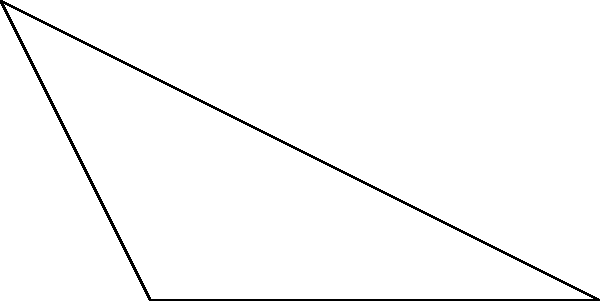Dearie, at the last concert, I noticed two microphone stands on stage forming an interesting angle. If one stand was 3 feet from the center of the stage and the other was $\sqrt{10}$ feet away, with an angle of $\theta$ between them, what's the cosine of that angle? It reminds me of those geometry problems from school! Let's work through this step-by-step, like solving a puzzle:

1) First, we can see a triangle formed by the two microphone stands and the center of the stage. Let's call the center point O, and the stands A and B.

2) We know that:
   OA = 3 feet
   OB = $\sqrt{10}$ feet
   Angle AOB = $\theta$

3) In trigonometry, there's a useful formula called the cosine law. It states that for a triangle with sides a, b, c and an angle C opposite side c:

   $c^2 = a^2 + b^2 - 2ab \cos(C)$

4) In our case, we want to find $\cos(\theta)$. We can use AB as our c, OA as a, and OB as b.

5) We don't know AB, but we can find it using the cosine law:

   $AB^2 = OA^2 + OB^2 - 2(OA)(OB)\cos(\theta)$

6) Now, let's rearrange this to solve for $\cos(\theta)$:

   $\cos(\theta) = \frac{OA^2 + OB^2 - AB^2}{2(OA)(OB)}$

7) We know OA and OB, but not AB. However, we don't need to! We're asked for $\cos(\theta)$, so this formula is exactly what we need.

8) Let's plug in the values:

   $\cos(\theta) = \frac{3^2 + (\sqrt{10})^2 - AB^2}{2(3)(\sqrt{10})}$

9) Simplify:

   $\cos(\theta) = \frac{9 + 10 - AB^2}{6\sqrt{10}}$

10) Final answer:

    $\cos(\theta) = \frac{19 - AB^2}{6\sqrt{10}}$
Answer: $\frac{19 - AB^2}{6\sqrt{10}}$ 